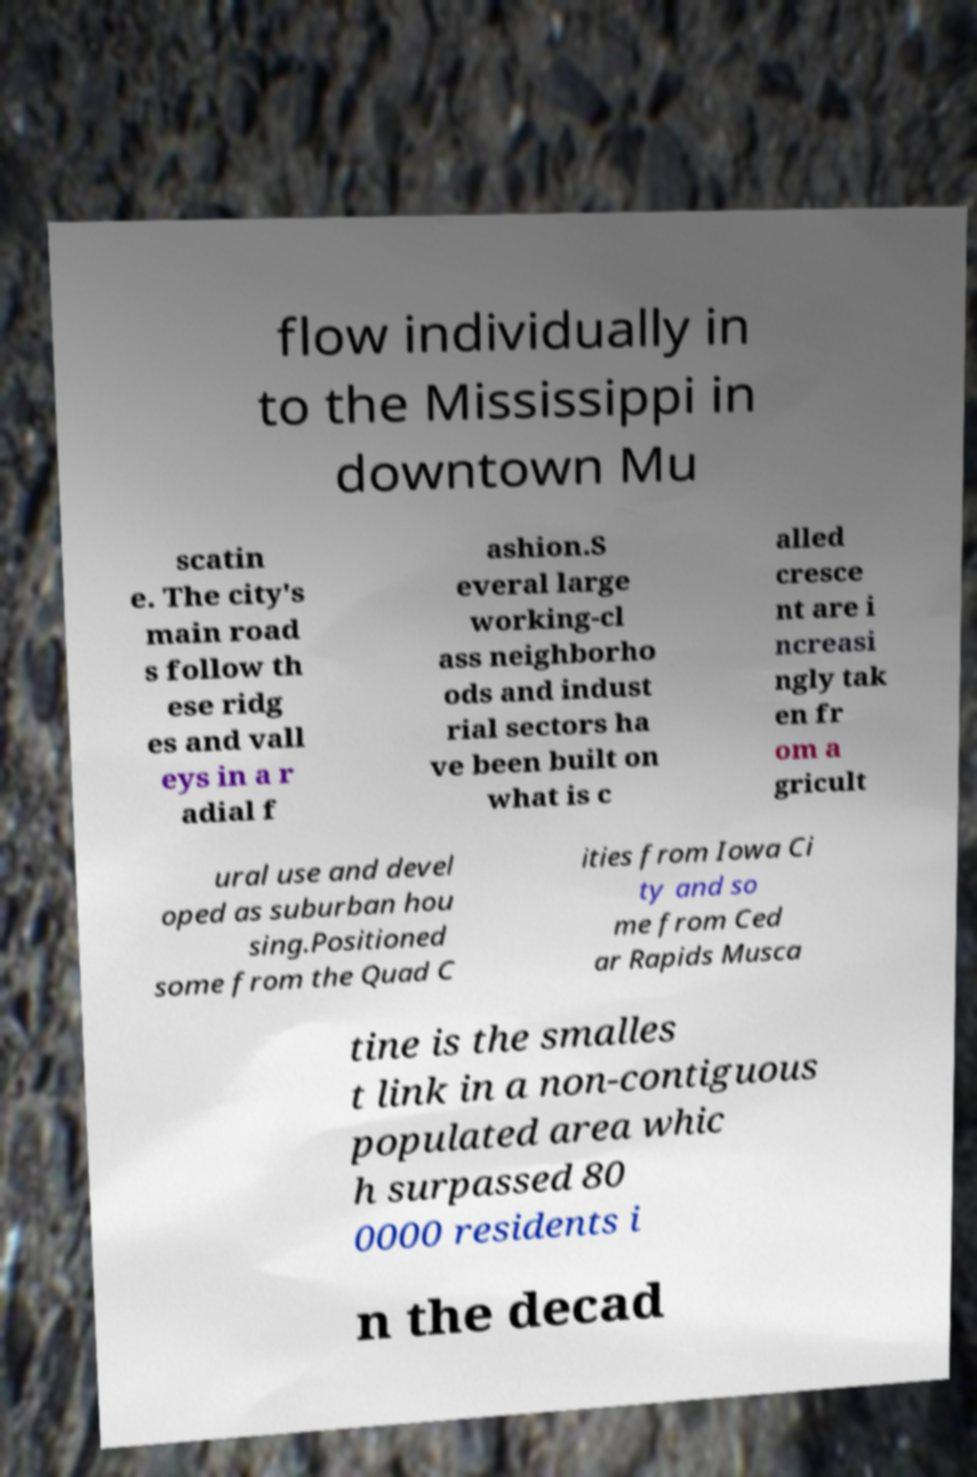Could you assist in decoding the text presented in this image and type it out clearly? flow individually in to the Mississippi in downtown Mu scatin e. The city's main road s follow th ese ridg es and vall eys in a r adial f ashion.S everal large working-cl ass neighborho ods and indust rial sectors ha ve been built on what is c alled cresce nt are i ncreasi ngly tak en fr om a gricult ural use and devel oped as suburban hou sing.Positioned some from the Quad C ities from Iowa Ci ty and so me from Ced ar Rapids Musca tine is the smalles t link in a non-contiguous populated area whic h surpassed 80 0000 residents i n the decad 